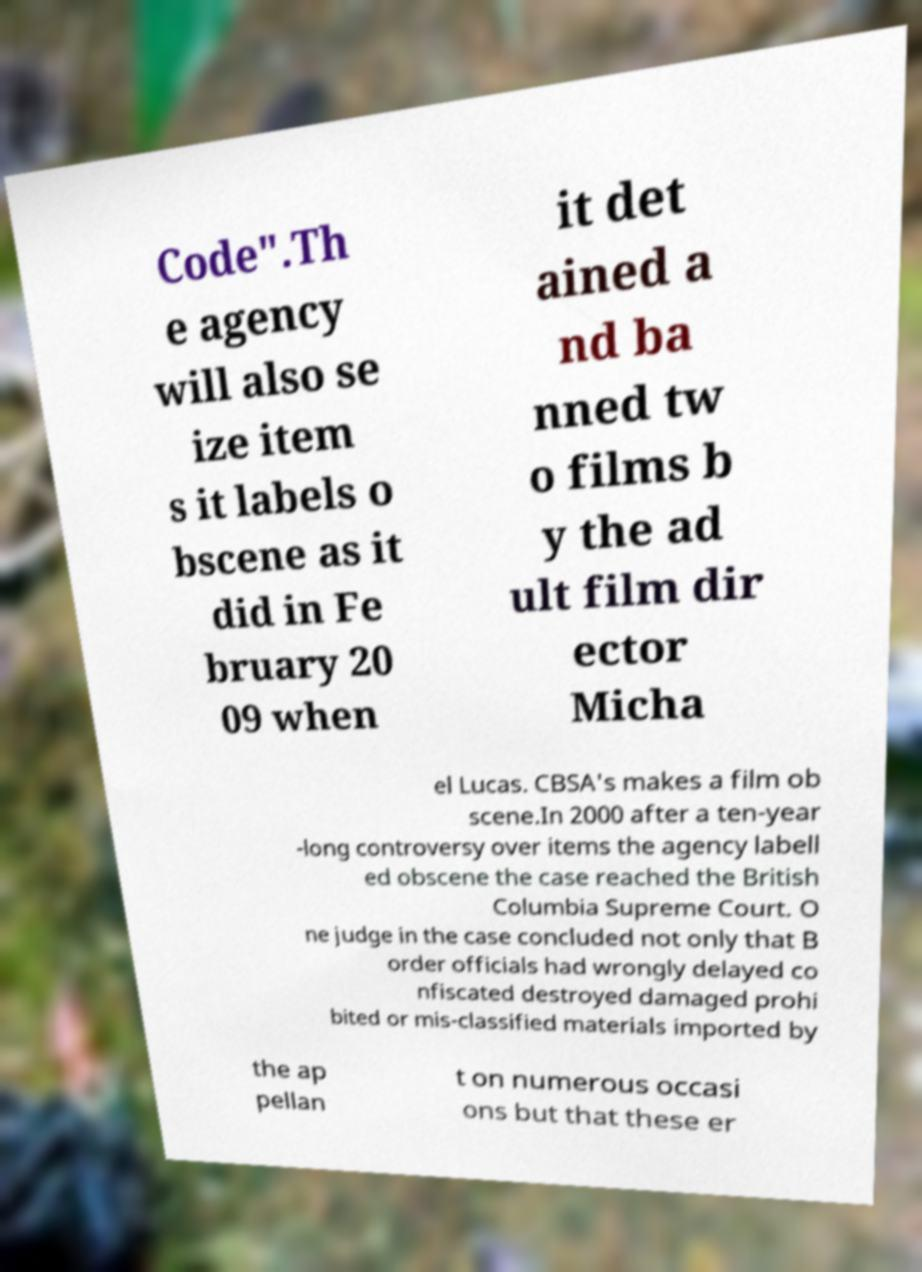I need the written content from this picture converted into text. Can you do that? Code".Th e agency will also se ize item s it labels o bscene as it did in Fe bruary 20 09 when it det ained a nd ba nned tw o films b y the ad ult film dir ector Micha el Lucas. CBSA's makes a film ob scene.In 2000 after a ten-year -long controversy over items the agency labell ed obscene the case reached the British Columbia Supreme Court. O ne judge in the case concluded not only that B order officials had wrongly delayed co nfiscated destroyed damaged prohi bited or mis-classified materials imported by the ap pellan t on numerous occasi ons but that these er 